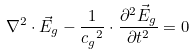Convert formula to latex. <formula><loc_0><loc_0><loc_500><loc_500>\nabla ^ { 2 } \cdot \vec { E } _ { g } - \frac { 1 } { { c _ { g } } ^ { 2 } } \cdot { \frac { \partial ^ { 2 } \vec { E } _ { g } } { \partial t ^ { 2 } } } = 0</formula> 